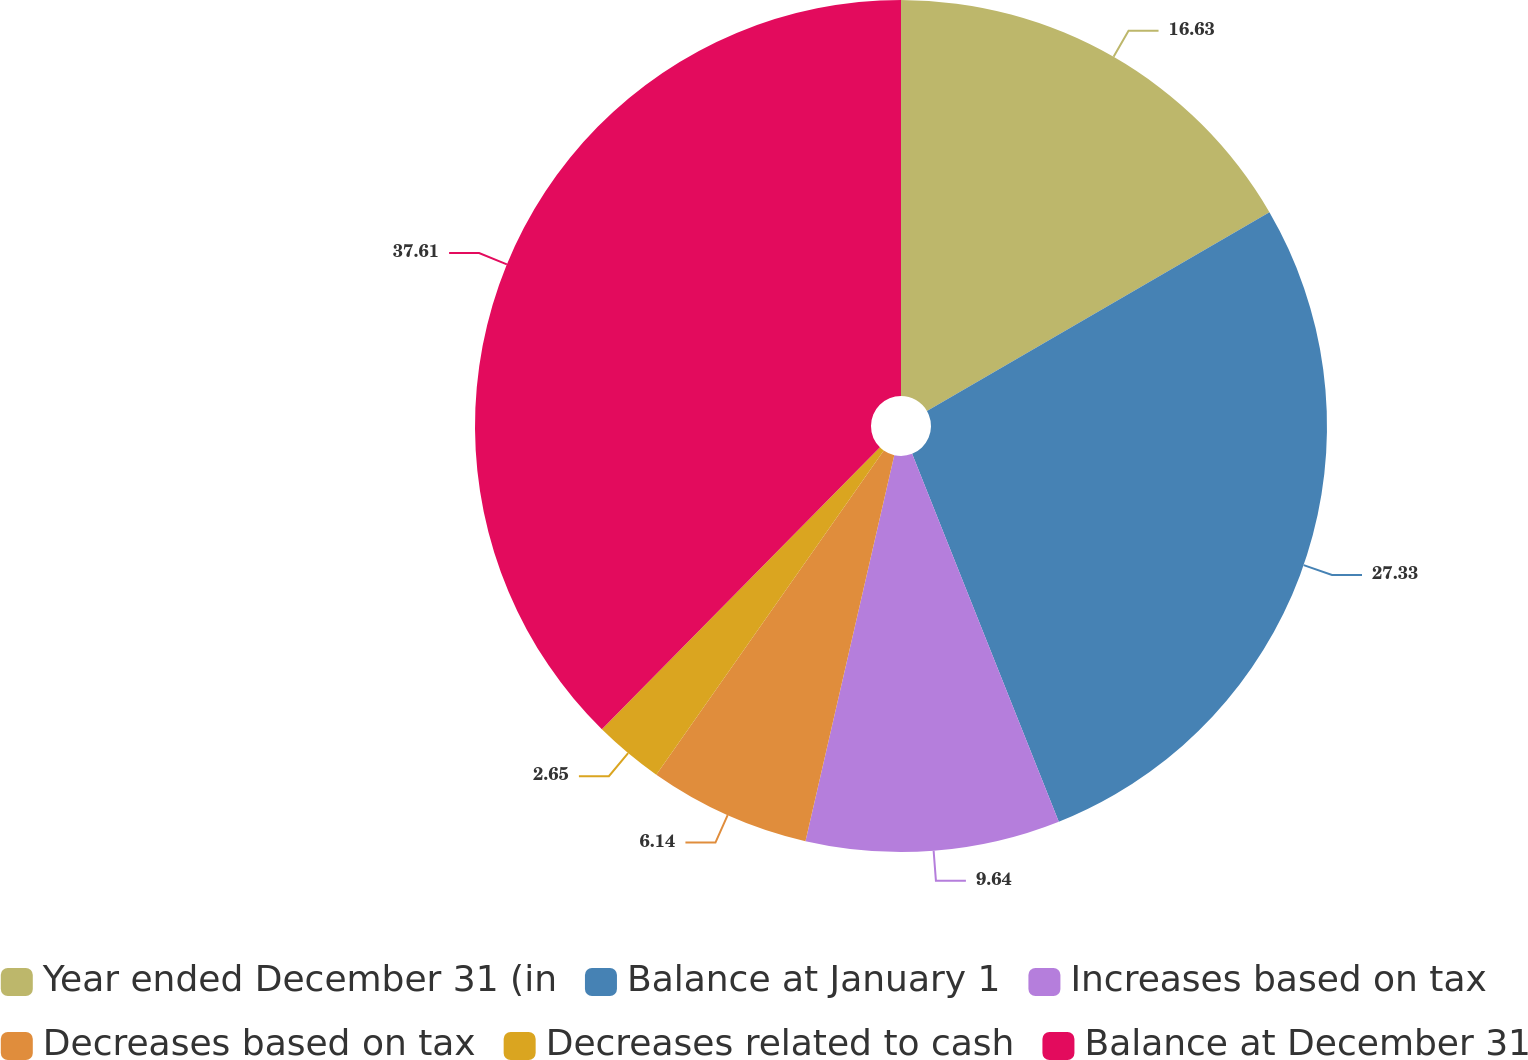<chart> <loc_0><loc_0><loc_500><loc_500><pie_chart><fcel>Year ended December 31 (in<fcel>Balance at January 1<fcel>Increases based on tax<fcel>Decreases based on tax<fcel>Decreases related to cash<fcel>Balance at December 31<nl><fcel>16.63%<fcel>27.33%<fcel>9.64%<fcel>6.14%<fcel>2.65%<fcel>37.61%<nl></chart> 